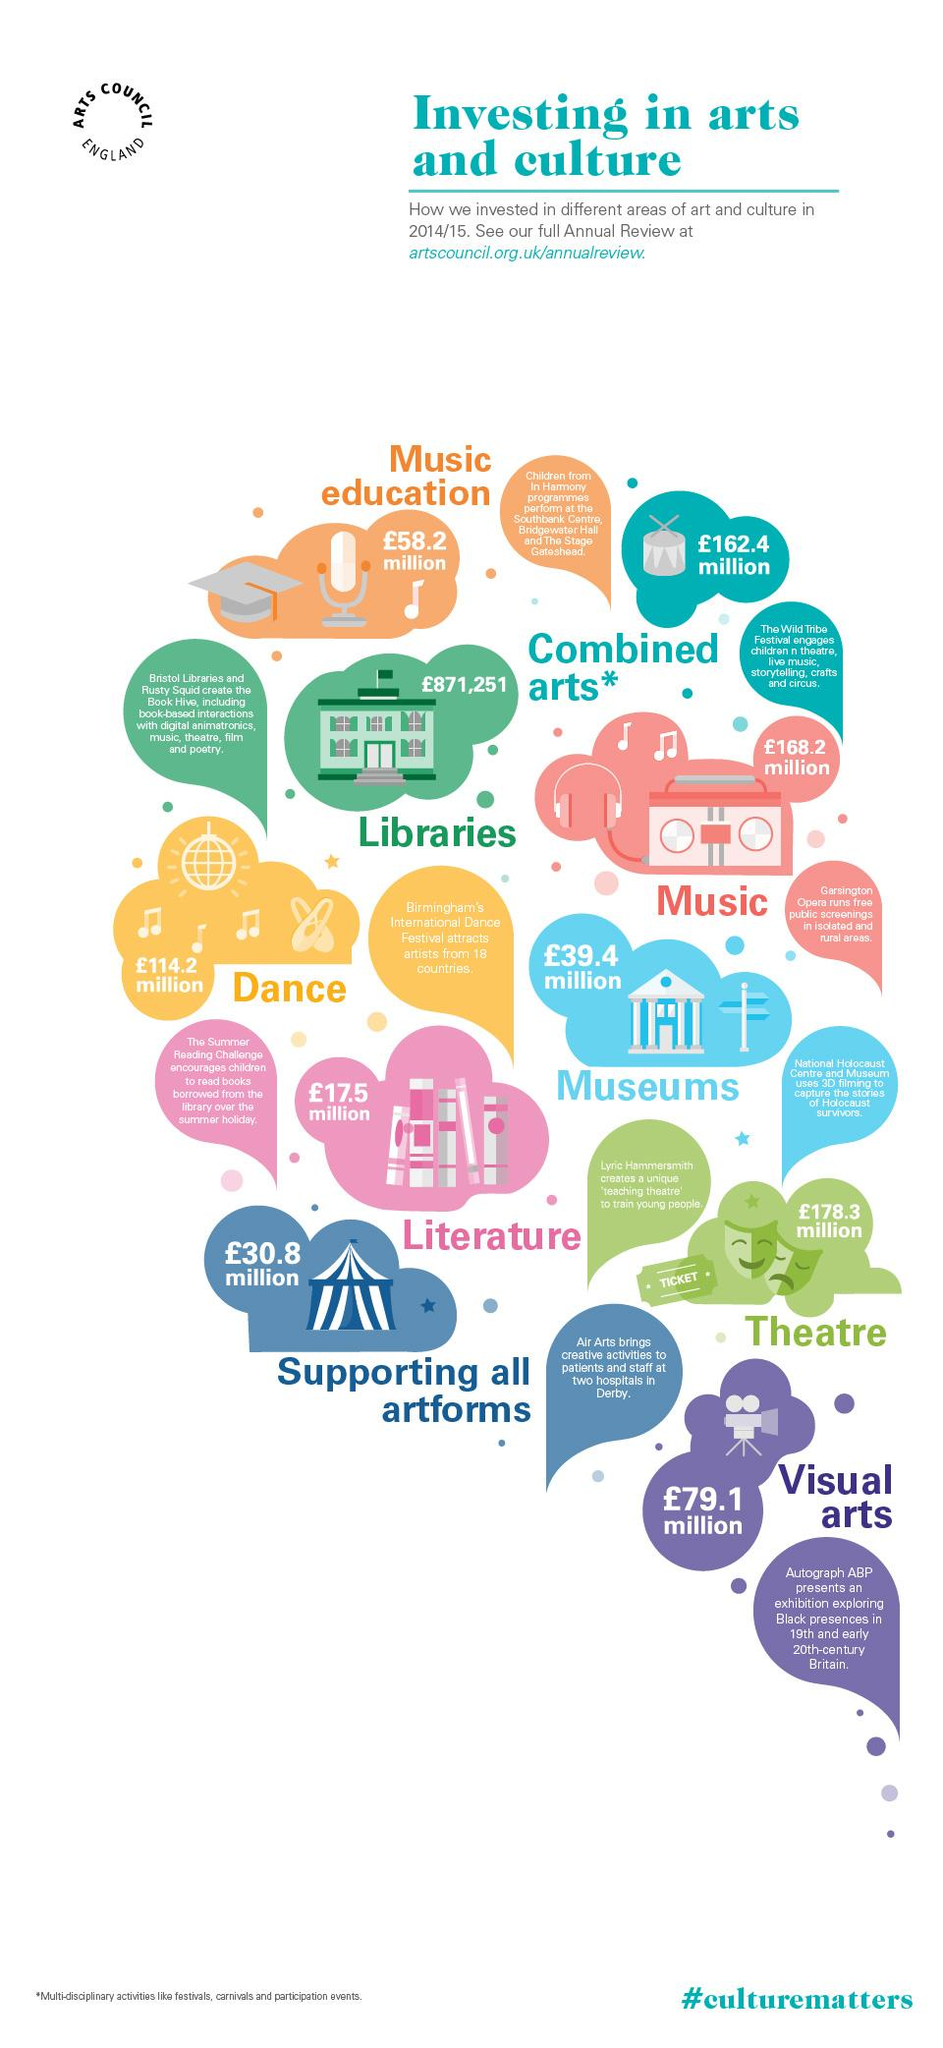Indicate a few pertinent items in this graphic. In the 2014/15 fiscal year, the United Kingdom invested approximately £17.5 million in the field of literature. In the 2014/15 fiscal year, the United Kingdom invested a total of £58.2 million in music education. In the year 2014/15, the UK government invested the least amount of money in the area of libraries, as part of its art and culture initiatives. In the 2014/15 fiscal year, the United Kingdom invested £178.3 million in theatre teaching. In 2014/15, the UK government invested the majority of its funds in the area of theatre, demonstrating its commitment to supporting and promoting the arts and culture sector. 